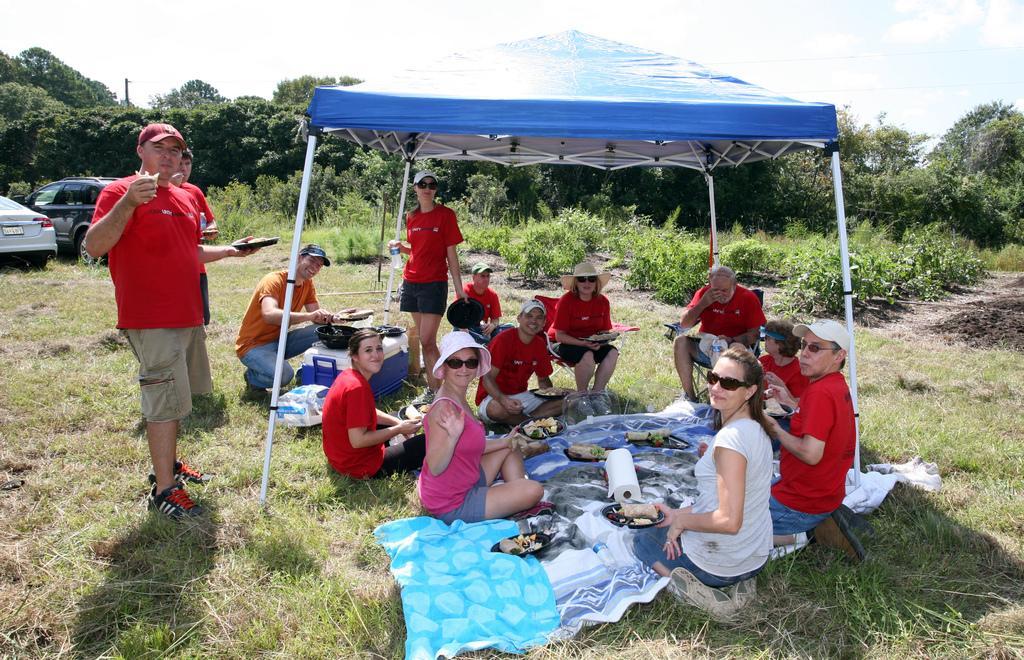In one or two sentences, can you explain what this image depicts? In the center of the image there is a tent. There are people sitting under the tent. There are food items in plates. To the left side of the image there is a person standing. There are cars. At the bottom of the image there is grass. In the background of the image there are trees,sky. 